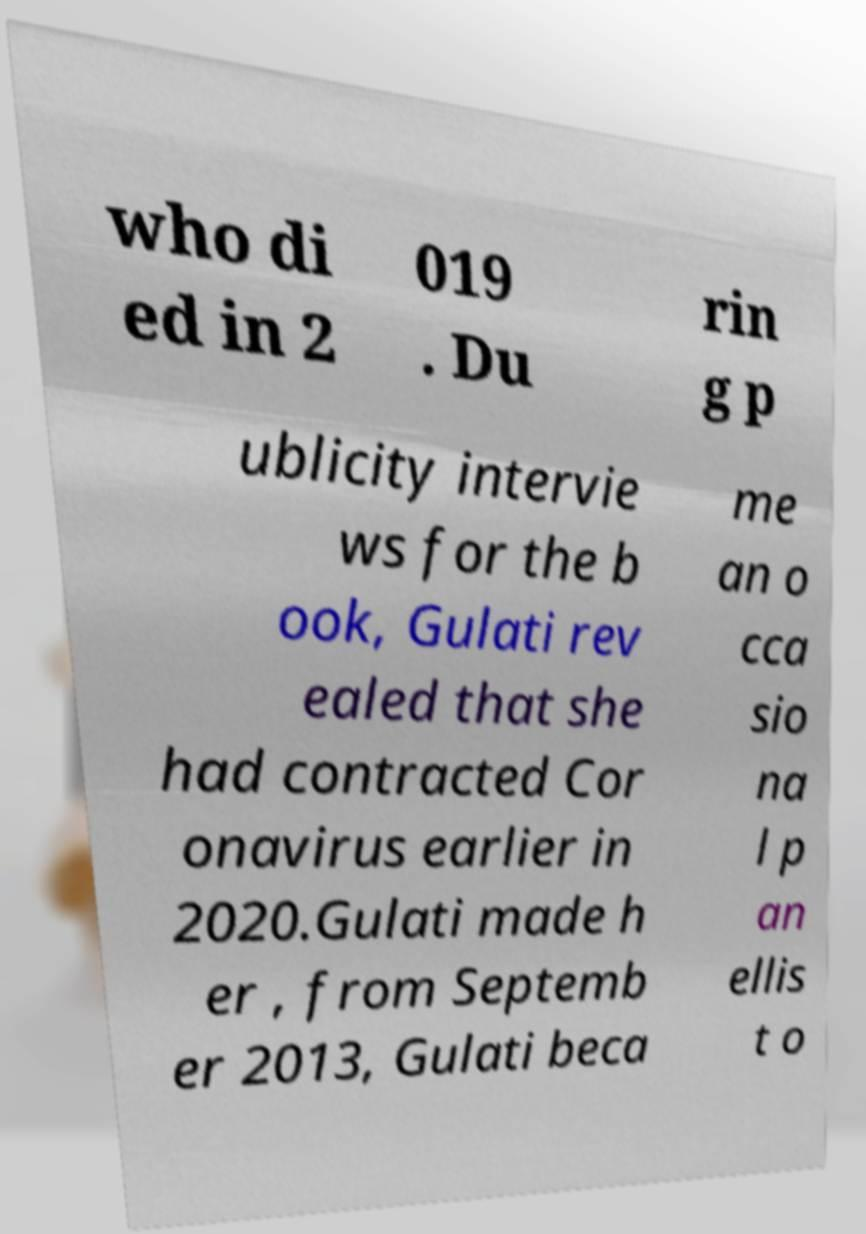Can you read and provide the text displayed in the image?This photo seems to have some interesting text. Can you extract and type it out for me? who di ed in 2 019 . Du rin g p ublicity intervie ws for the b ook, Gulati rev ealed that she had contracted Cor onavirus earlier in 2020.Gulati made h er , from Septemb er 2013, Gulati beca me an o cca sio na l p an ellis t o 